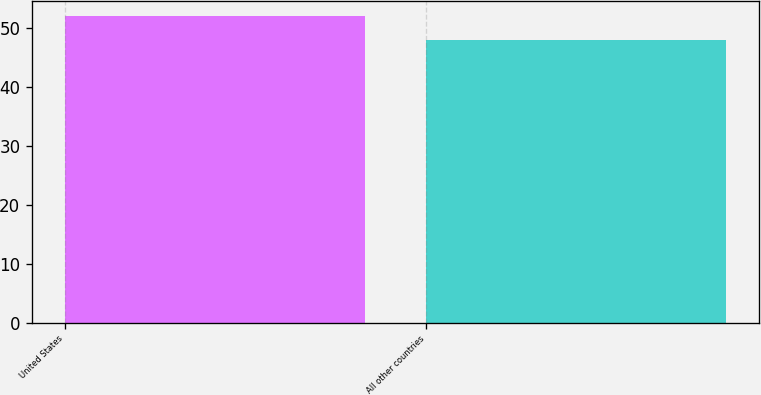Convert chart. <chart><loc_0><loc_0><loc_500><loc_500><bar_chart><fcel>United States<fcel>All other countries<nl><fcel>52<fcel>48<nl></chart> 